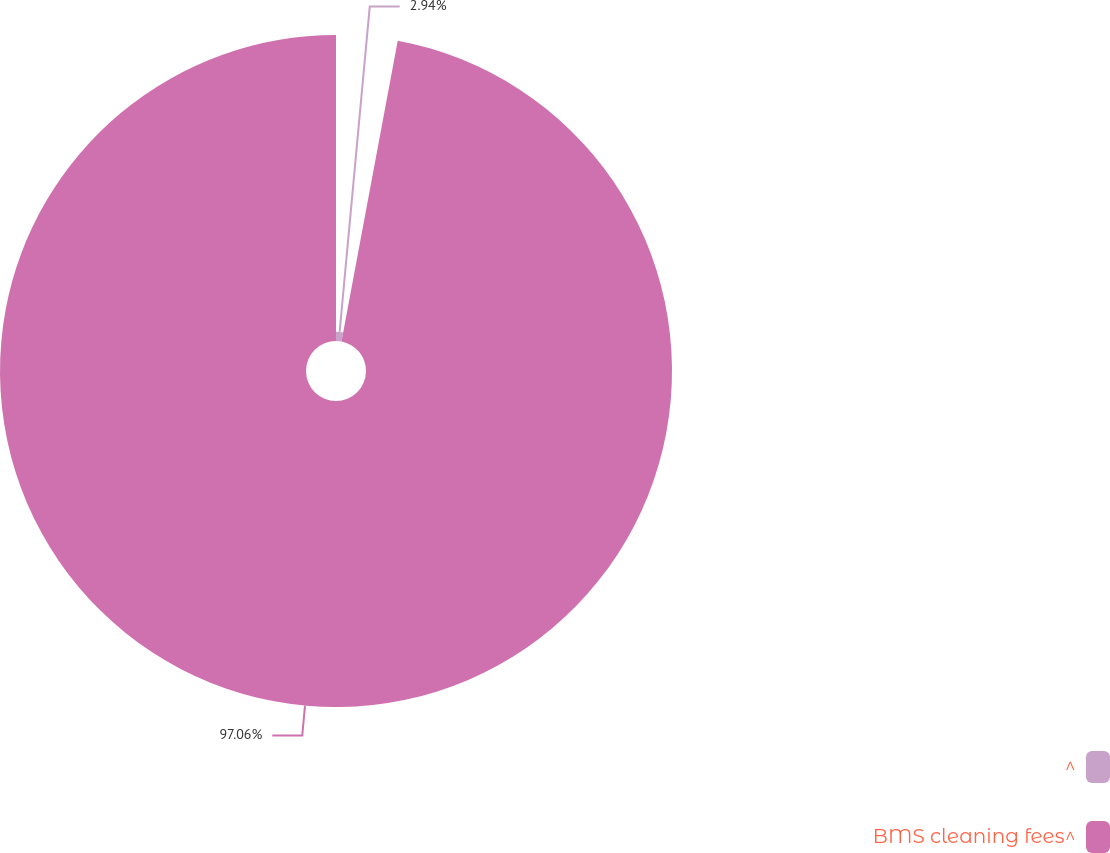Convert chart. <chart><loc_0><loc_0><loc_500><loc_500><pie_chart><fcel>^<fcel>BMS cleaning fees^<nl><fcel>2.94%<fcel>97.06%<nl></chart> 